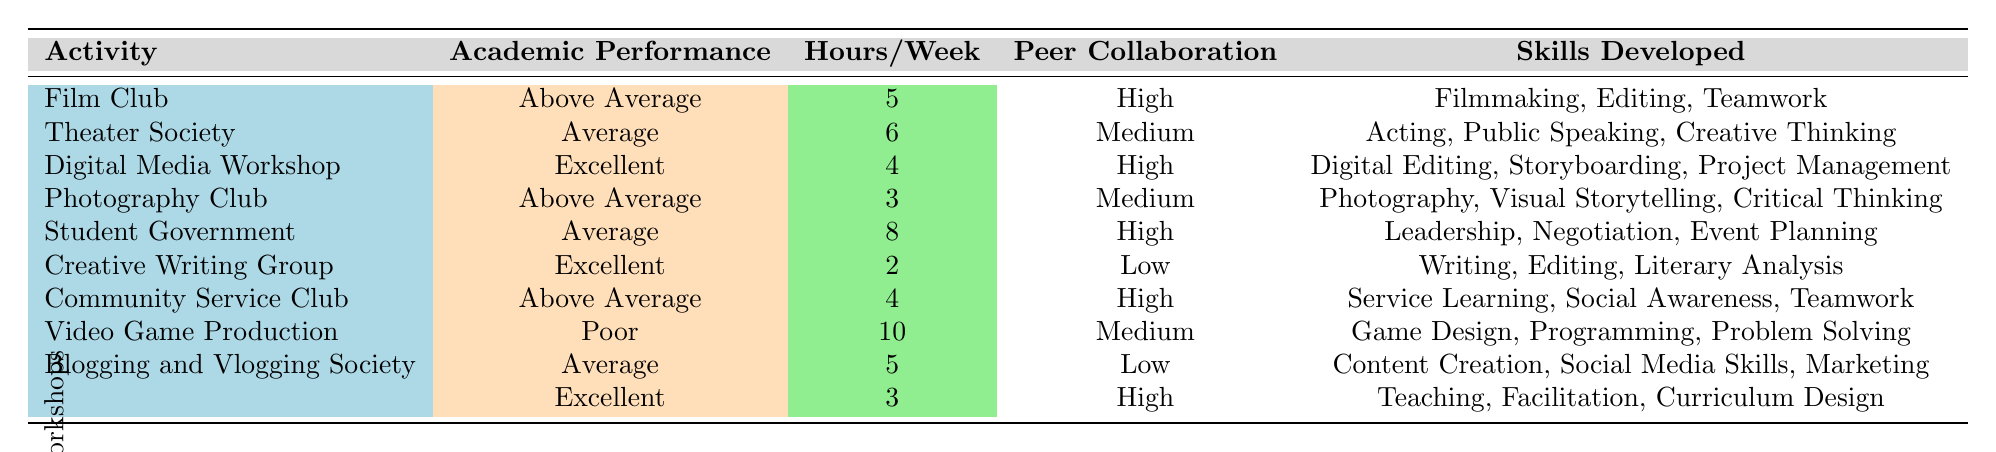What's the academic performance of the Digital Media Workshop? The table indicates that the academic performance of the Digital Media Workshop is categorized as "Excellent."
Answer: Excellent Which extracurricular activity has the highest hours per week? By scanning the "Hours/Week" column, we see that the Video Game Production activity has the highest recorded hours at 10.
Answer: Video Game Production What is the average number of hours per week spent on extracurricular activities categorized as "Above Average"? The activities categorized as "Above Average" are Film Club, Photography Club, and Community Service Club. They have hours of 5, 3, and 4 respectively. The sum is 5 + 3 + 4 = 12. Dividing by the number of activities (3), we find the average is 12/3 = 4.
Answer: 4 Is there an activity with "Low" peer collaboration that also has "Excellent" academic performance? The Creative Writing Group has "Low" peer collaboration and is categorized as "Excellent" in academic performance, confirming that the statement is true.
Answer: Yes Which extracurricular activity exhibits the most diverse skill set based on the skills developed? By examining the skills developed for each activity, we note that Digital Media Workshop, and Student-led Workshops both list three diverse skills. The Digital Media Workshop includes Digital Editing, Storyboarding, and Project Management while Student-led Workshops includes Teaching, Facilitation, and Curriculum Design. Therefore, both have equal diversity.
Answer: Tie between Digital Media Workshop and Student-led Workshops What percentage of activities result in either "Excellent" or "Above Average" academic performance? There are 3 activities classified as "Excellent" and 4 as "Above Average," making a total of 7 successful activities out of 10 total activities. To find the percentage: (7/10) * 100 = 70%.
Answer: 70% How many activities require more than 5 hours per week and achieve an "Average" academic performance? There are two activities classified with "Average" performance: Theater Society (6 hours) and Student Government (8 hours). Both require more than 5 hours per week, giving us a total of 2 activities.
Answer: 2 What is the skill set of the Student Government activity? The table lists the skills developed for Student Government as Leadership, Negotiation, and Event Planning, which shows that this activity emphasizes organizational and leadership skills.
Answer: Leadership, Negotiation, Event Planning 